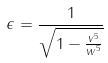<formula> <loc_0><loc_0><loc_500><loc_500>\epsilon = \frac { 1 } { \sqrt { 1 - \frac { v ^ { 5 } } { w ^ { 5 } } } }</formula> 